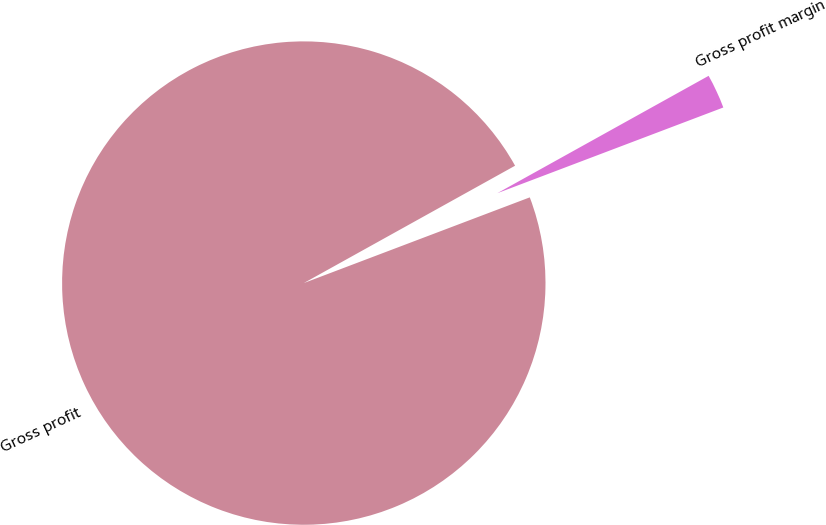Convert chart to OTSL. <chart><loc_0><loc_0><loc_500><loc_500><pie_chart><fcel>Gross profit<fcel>Gross profit margin<nl><fcel>97.7%<fcel>2.3%<nl></chart> 